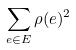Convert formula to latex. <formula><loc_0><loc_0><loc_500><loc_500>\sum _ { e \in E } \rho ( e ) ^ { 2 }</formula> 